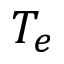<formula> <loc_0><loc_0><loc_500><loc_500>T _ { e }</formula> 